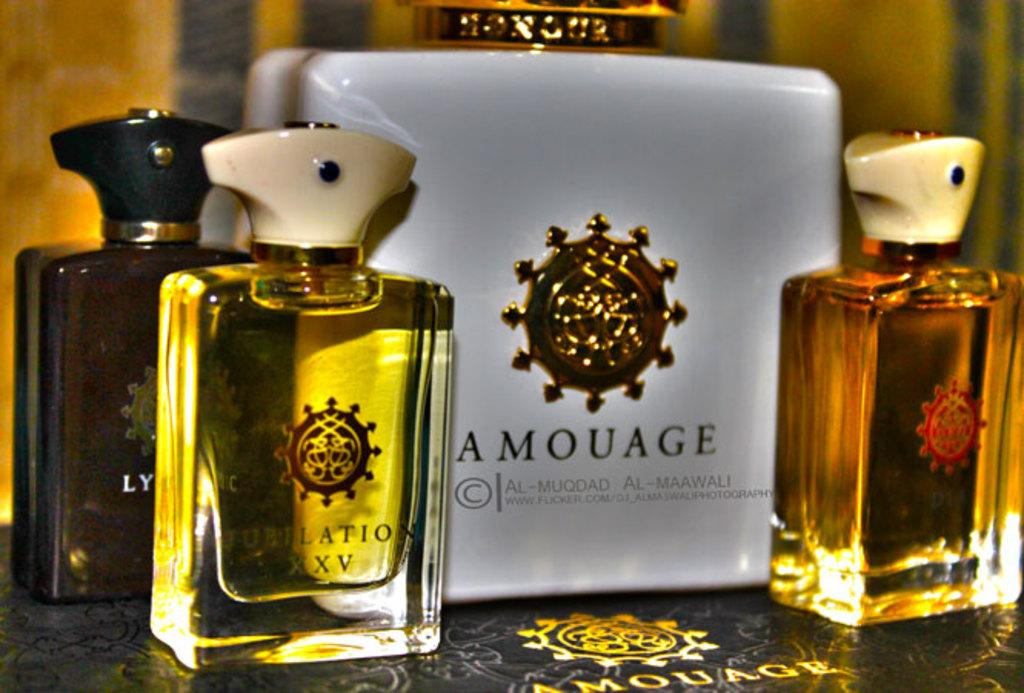Provide a one-sentence caption for the provided image. Amouage makes several different items, including Jubilation XXV. 